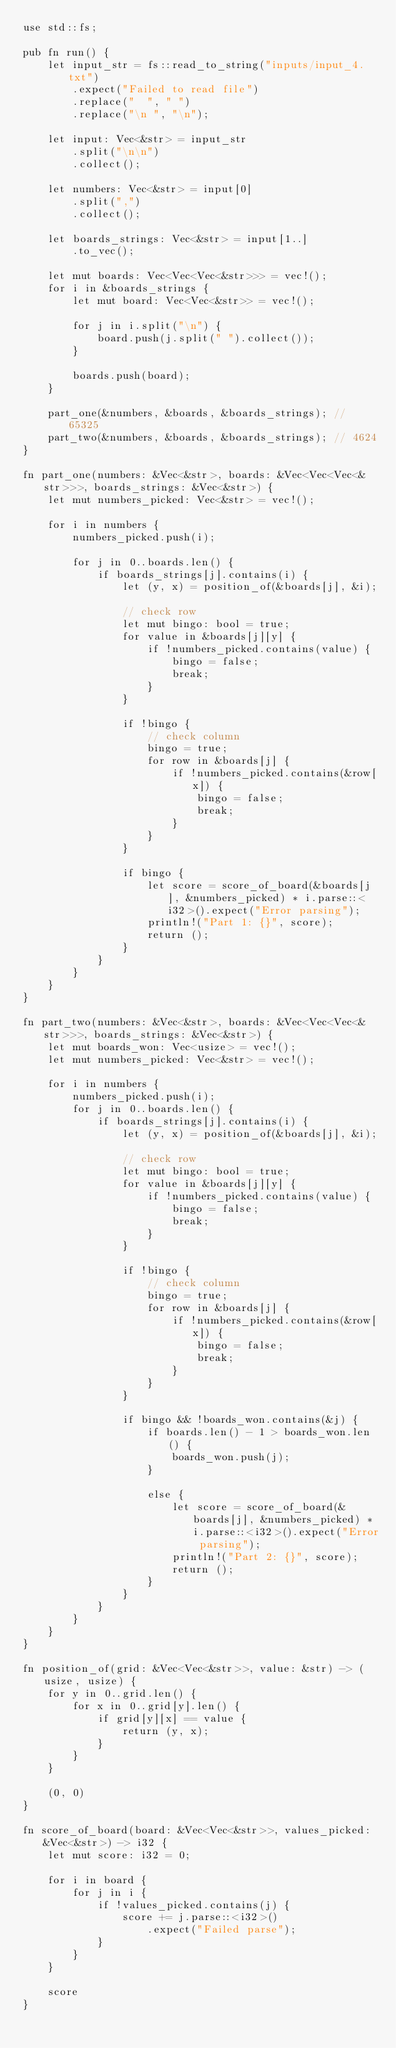<code> <loc_0><loc_0><loc_500><loc_500><_Rust_>use std::fs;

pub fn run() {
    let input_str = fs::read_to_string("inputs/input_4.txt")
        .expect("Failed to read file")
        .replace("  ", " ")
        .replace("\n ", "\n");

    let input: Vec<&str> = input_str
        .split("\n\n")
        .collect();

    let numbers: Vec<&str> = input[0]
        .split(",")
        .collect();

    let boards_strings: Vec<&str> = input[1..]
        .to_vec();

    let mut boards: Vec<Vec<Vec<&str>>> = vec!();
    for i in &boards_strings {
        let mut board: Vec<Vec<&str>> = vec!();

        for j in i.split("\n") {
            board.push(j.split(" ").collect());
        }

        boards.push(board);
    }

    part_one(&numbers, &boards, &boards_strings); // 65325
    part_two(&numbers, &boards, &boards_strings); // 4624
}

fn part_one(numbers: &Vec<&str>, boards: &Vec<Vec<Vec<&str>>>, boards_strings: &Vec<&str>) {
    let mut numbers_picked: Vec<&str> = vec!();

    for i in numbers {
        numbers_picked.push(i);

        for j in 0..boards.len() {
            if boards_strings[j].contains(i) {
                let (y, x) = position_of(&boards[j], &i);

                // check row
                let mut bingo: bool = true;
                for value in &boards[j][y] {
                    if !numbers_picked.contains(value) {
                        bingo = false;
                        break;
                    }
                }

                if !bingo {
                    // check column
                    bingo = true;
                    for row in &boards[j] {
                        if !numbers_picked.contains(&row[x]) {
                            bingo = false;
                            break;
                        }
                    }
                }

                if bingo {
                    let score = score_of_board(&boards[j], &numbers_picked) * i.parse::<i32>().expect("Error parsing");
                    println!("Part 1: {}", score);
                    return ();
                }
            }
        }
    }
}

fn part_two(numbers: &Vec<&str>, boards: &Vec<Vec<Vec<&str>>>, boards_strings: &Vec<&str>) {
    let mut boards_won: Vec<usize> = vec!();
    let mut numbers_picked: Vec<&str> = vec!();

    for i in numbers {
        numbers_picked.push(i);
        for j in 0..boards.len() {
            if boards_strings[j].contains(i) {
                let (y, x) = position_of(&boards[j], &i);

                // check row
                let mut bingo: bool = true;
                for value in &boards[j][y] {
                    if !numbers_picked.contains(value) {
                        bingo = false;
                        break;
                    }
                }

                if !bingo {
                    // check column
                    bingo = true;
                    for row in &boards[j] {
                        if !numbers_picked.contains(&row[x]) {
                            bingo = false;
                            break;
                        }
                    }
                }

                if bingo && !boards_won.contains(&j) {
                    if boards.len() - 1 > boards_won.len() {
                        boards_won.push(j);
                    }

                    else {
                        let score = score_of_board(&boards[j], &numbers_picked) * i.parse::<i32>().expect("Error parsing");
                        println!("Part 2: {}", score);
                        return ();
                    }
                }
            }
        }
    }
}

fn position_of(grid: &Vec<Vec<&str>>, value: &str) -> (usize, usize) {
    for y in 0..grid.len() {
        for x in 0..grid[y].len() {
            if grid[y][x] == value {
                return (y, x);
            }
        }
    }

    (0, 0)
}

fn score_of_board(board: &Vec<Vec<&str>>, values_picked: &Vec<&str>) -> i32 {
    let mut score: i32 = 0;

    for i in board {
        for j in i {
            if !values_picked.contains(j) {
                score += j.parse::<i32>()
                    .expect("Failed parse");
            }
        }
    }

    score
}
</code> 